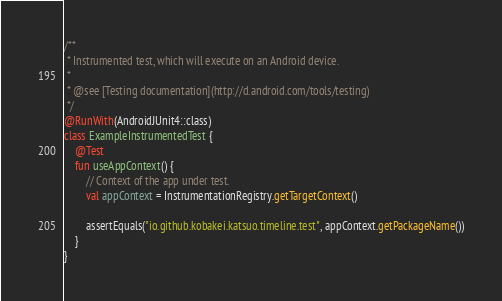<code> <loc_0><loc_0><loc_500><loc_500><_Kotlin_>
/**
 * Instrumented test, which will execute on an Android device.
 *
 * @see [Testing documentation](http://d.android.com/tools/testing)
 */
@RunWith(AndroidJUnit4::class)
class ExampleInstrumentedTest {
    @Test
    fun useAppContext() {
        // Context of the app under test.
        val appContext = InstrumentationRegistry.getTargetContext()

        assertEquals("io.github.kobakei.katsuo.timeline.test", appContext.getPackageName())
    }
}
</code> 